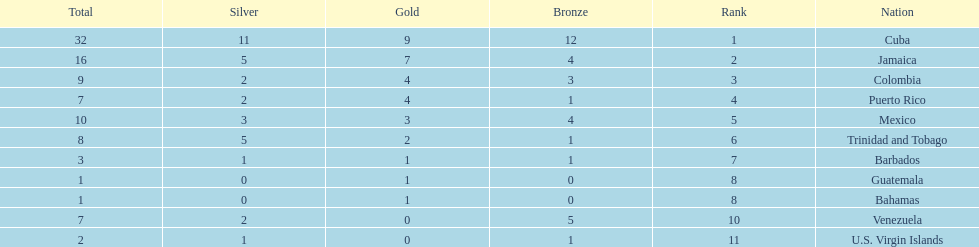Only team to have more than 30 medals Cuba. 